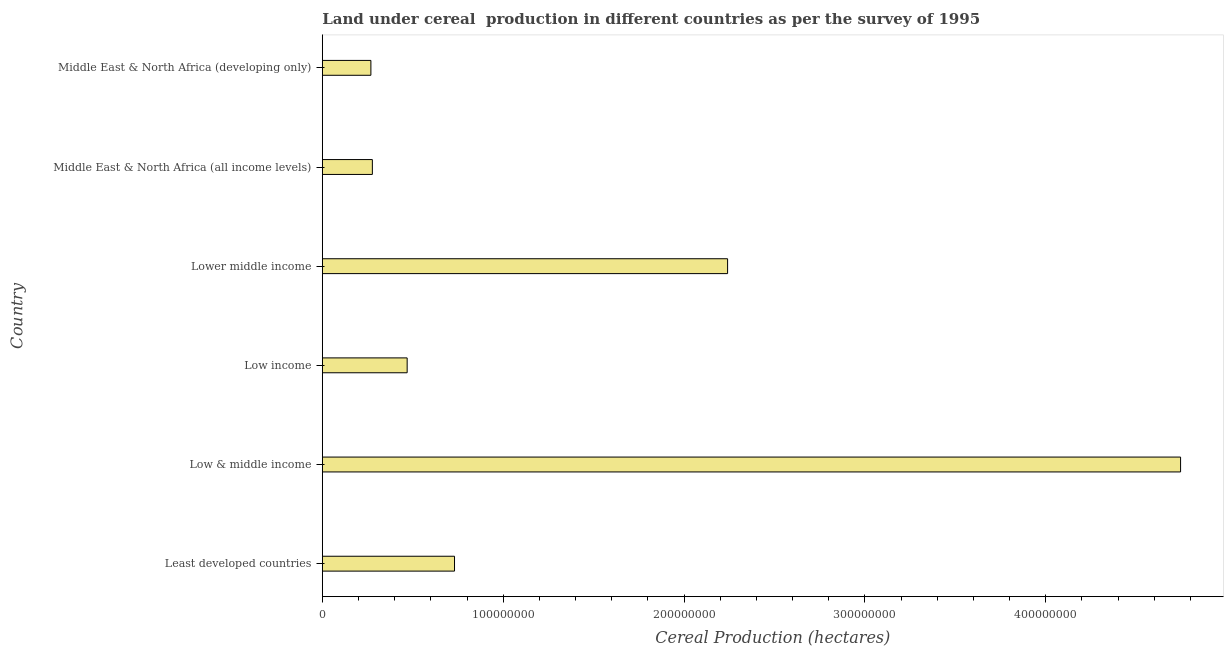Does the graph contain any zero values?
Your response must be concise. No. What is the title of the graph?
Provide a short and direct response. Land under cereal  production in different countries as per the survey of 1995. What is the label or title of the X-axis?
Ensure brevity in your answer.  Cereal Production (hectares). What is the land under cereal production in Least developed countries?
Ensure brevity in your answer.  7.31e+07. Across all countries, what is the maximum land under cereal production?
Offer a terse response. 4.75e+08. Across all countries, what is the minimum land under cereal production?
Offer a terse response. 2.69e+07. In which country was the land under cereal production minimum?
Provide a short and direct response. Middle East & North Africa (developing only). What is the sum of the land under cereal production?
Offer a terse response. 8.73e+08. What is the difference between the land under cereal production in Lower middle income and Middle East & North Africa (developing only)?
Make the answer very short. 1.97e+08. What is the average land under cereal production per country?
Offer a terse response. 1.46e+08. What is the median land under cereal production?
Make the answer very short. 6.00e+07. What is the ratio of the land under cereal production in Least developed countries to that in Lower middle income?
Keep it short and to the point. 0.33. Is the land under cereal production in Least developed countries less than that in Middle East & North Africa (all income levels)?
Give a very brief answer. No. What is the difference between the highest and the second highest land under cereal production?
Offer a very short reply. 2.51e+08. What is the difference between the highest and the lowest land under cereal production?
Make the answer very short. 4.48e+08. How many bars are there?
Offer a very short reply. 6. Are all the bars in the graph horizontal?
Your answer should be compact. Yes. How many countries are there in the graph?
Your answer should be very brief. 6. Are the values on the major ticks of X-axis written in scientific E-notation?
Give a very brief answer. No. What is the Cereal Production (hectares) in Least developed countries?
Provide a succinct answer. 7.31e+07. What is the Cereal Production (hectares) of Low & middle income?
Offer a very short reply. 4.75e+08. What is the Cereal Production (hectares) of Low income?
Your answer should be very brief. 4.69e+07. What is the Cereal Production (hectares) of Lower middle income?
Ensure brevity in your answer.  2.24e+08. What is the Cereal Production (hectares) of Middle East & North Africa (all income levels)?
Make the answer very short. 2.77e+07. What is the Cereal Production (hectares) of Middle East & North Africa (developing only)?
Your answer should be very brief. 2.69e+07. What is the difference between the Cereal Production (hectares) in Least developed countries and Low & middle income?
Offer a terse response. -4.02e+08. What is the difference between the Cereal Production (hectares) in Least developed countries and Low income?
Provide a short and direct response. 2.62e+07. What is the difference between the Cereal Production (hectares) in Least developed countries and Lower middle income?
Your response must be concise. -1.51e+08. What is the difference between the Cereal Production (hectares) in Least developed countries and Middle East & North Africa (all income levels)?
Offer a terse response. 4.54e+07. What is the difference between the Cereal Production (hectares) in Least developed countries and Middle East & North Africa (developing only)?
Provide a short and direct response. 4.62e+07. What is the difference between the Cereal Production (hectares) in Low & middle income and Low income?
Offer a terse response. 4.28e+08. What is the difference between the Cereal Production (hectares) in Low & middle income and Lower middle income?
Make the answer very short. 2.51e+08. What is the difference between the Cereal Production (hectares) in Low & middle income and Middle East & North Africa (all income levels)?
Your response must be concise. 4.47e+08. What is the difference between the Cereal Production (hectares) in Low & middle income and Middle East & North Africa (developing only)?
Your response must be concise. 4.48e+08. What is the difference between the Cereal Production (hectares) in Low income and Lower middle income?
Provide a succinct answer. -1.77e+08. What is the difference between the Cereal Production (hectares) in Low income and Middle East & North Africa (all income levels)?
Offer a terse response. 1.92e+07. What is the difference between the Cereal Production (hectares) in Low income and Middle East & North Africa (developing only)?
Your answer should be very brief. 2.01e+07. What is the difference between the Cereal Production (hectares) in Lower middle income and Middle East & North Africa (all income levels)?
Your answer should be very brief. 1.96e+08. What is the difference between the Cereal Production (hectares) in Lower middle income and Middle East & North Africa (developing only)?
Your answer should be very brief. 1.97e+08. What is the difference between the Cereal Production (hectares) in Middle East & North Africa (all income levels) and Middle East & North Africa (developing only)?
Give a very brief answer. 8.12e+05. What is the ratio of the Cereal Production (hectares) in Least developed countries to that in Low & middle income?
Keep it short and to the point. 0.15. What is the ratio of the Cereal Production (hectares) in Least developed countries to that in Low income?
Offer a terse response. 1.56. What is the ratio of the Cereal Production (hectares) in Least developed countries to that in Lower middle income?
Your answer should be compact. 0.33. What is the ratio of the Cereal Production (hectares) in Least developed countries to that in Middle East & North Africa (all income levels)?
Keep it short and to the point. 2.64. What is the ratio of the Cereal Production (hectares) in Least developed countries to that in Middle East & North Africa (developing only)?
Your response must be concise. 2.72. What is the ratio of the Cereal Production (hectares) in Low & middle income to that in Low income?
Your response must be concise. 10.12. What is the ratio of the Cereal Production (hectares) in Low & middle income to that in Lower middle income?
Offer a terse response. 2.12. What is the ratio of the Cereal Production (hectares) in Low & middle income to that in Middle East & North Africa (all income levels)?
Offer a very short reply. 17.15. What is the ratio of the Cereal Production (hectares) in Low & middle income to that in Middle East & North Africa (developing only)?
Offer a terse response. 17.67. What is the ratio of the Cereal Production (hectares) in Low income to that in Lower middle income?
Ensure brevity in your answer.  0.21. What is the ratio of the Cereal Production (hectares) in Low income to that in Middle East & North Africa (all income levels)?
Give a very brief answer. 1.7. What is the ratio of the Cereal Production (hectares) in Low income to that in Middle East & North Africa (developing only)?
Your answer should be compact. 1.75. What is the ratio of the Cereal Production (hectares) in Lower middle income to that in Middle East & North Africa (all income levels)?
Your answer should be compact. 8.1. What is the ratio of the Cereal Production (hectares) in Lower middle income to that in Middle East & North Africa (developing only)?
Your answer should be compact. 8.35. 